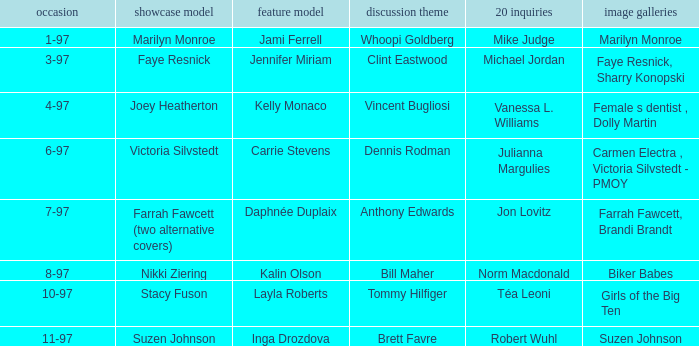Who was the interview subject on the date 1-97? Whoopi Goldberg. 